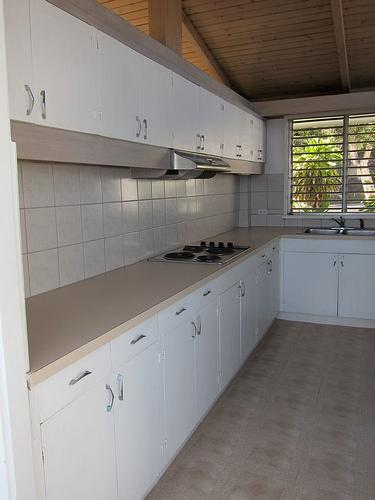Explain the function of the beige-colored backsplash tile in the kitchen. The beige-colored backsplash tile serves as a protective and decorative element on the wall, preventing stains and damage from splashes while enhancing the aesthetic appeal of the room. Provide an overall assessment of the image quality. The image quality is high, with clear object boundaries and sufficient detail, allowing for various tasks such as object recognition and sentiment analysis. Count the number of handles found in the image. There are a total of 11 handles in the image, located on upper and lower cabinets, drawers, and white cabinets. How many trees can be seen outside the window? There is one visible tree outside the window. Describe the features of the window in the image. The window has a wooden frame, is positioned on the rear wall, and is adorned with a pair of open horizontal blinds, revealing trees outside. Identify two objects related to water usage in the image. The stainless steel double sink and the stainless steel faucet above it are both related to water usage in the image. Provide a brief description of the most significant items seen in the picture. The image features a kitchen with a built-in cooktop stove, stainless steel double sink, white cabinets, beige countertop, wooden ceiling, and a window with horizontal blinds. Explain the role of the wooden pillar in the room. The wooden pillar serves as a support beam for the structure, ensuring the stability and integrity of the building. Analyze the sentiment of the kitchen in the image. The sentiment of the kitchen is positive and inviting, with its clean design, light-colored floor, white cabinets, and attractive wooden details. Identify the objects related to cooking in the image. Objects related to cooking include a built-in cooktop stove with four burners, black knobs, and a silver range hood installed on the wall above it. 